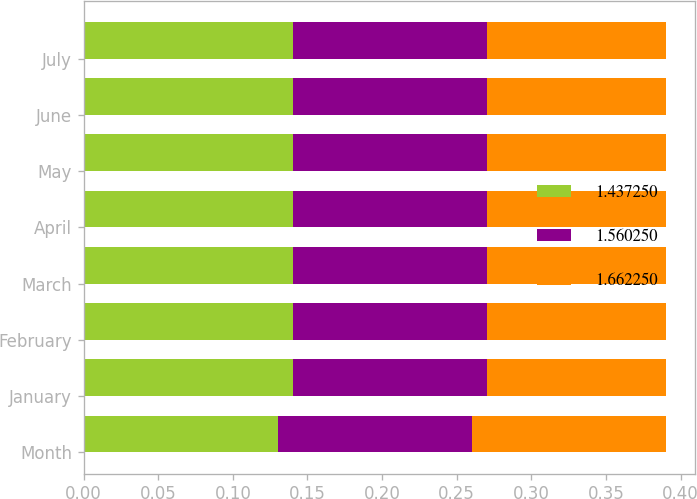<chart> <loc_0><loc_0><loc_500><loc_500><stacked_bar_chart><ecel><fcel>Month<fcel>January<fcel>February<fcel>March<fcel>April<fcel>May<fcel>June<fcel>July<nl><fcel>1.43725<fcel>0.13<fcel>0.14<fcel>0.14<fcel>0.14<fcel>0.14<fcel>0.14<fcel>0.14<fcel>0.14<nl><fcel>1.56025<fcel>0.13<fcel>0.13<fcel>0.13<fcel>0.13<fcel>0.13<fcel>0.13<fcel>0.13<fcel>0.13<nl><fcel>1.66225<fcel>0.13<fcel>0.12<fcel>0.12<fcel>0.12<fcel>0.12<fcel>0.12<fcel>0.12<fcel>0.12<nl></chart> 